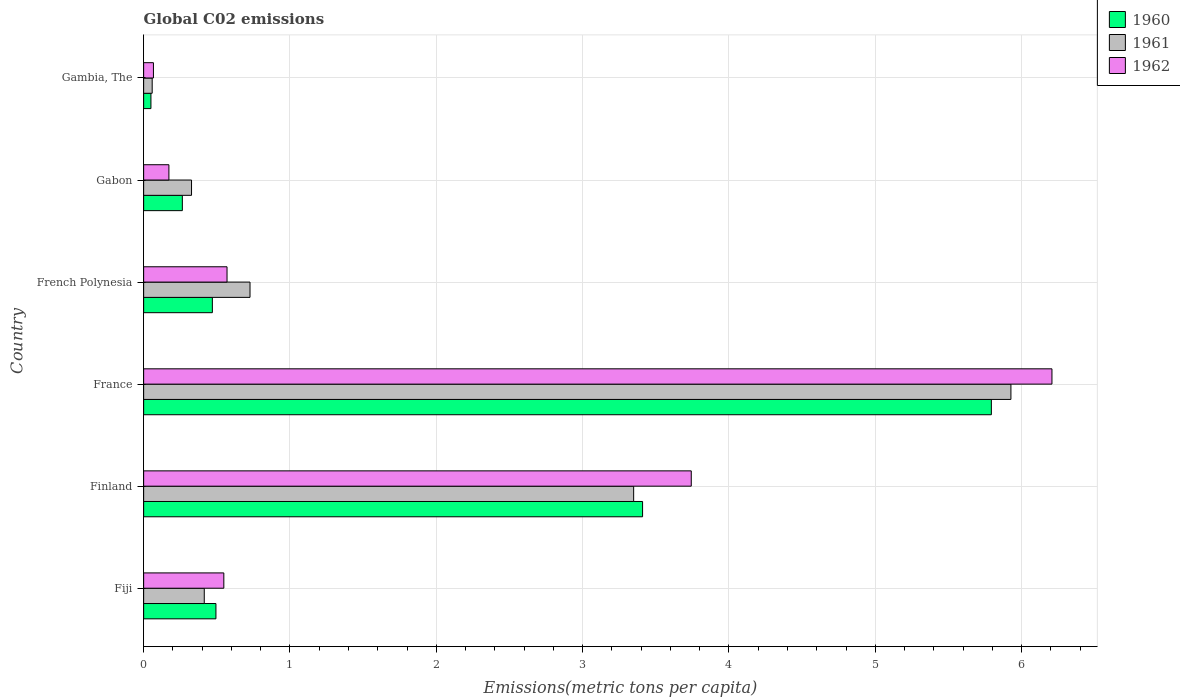Are the number of bars per tick equal to the number of legend labels?
Offer a terse response. Yes. How many bars are there on the 6th tick from the bottom?
Keep it short and to the point. 3. What is the label of the 4th group of bars from the top?
Your answer should be compact. France. What is the amount of CO2 emitted in in 1960 in France?
Your answer should be compact. 5.79. Across all countries, what is the maximum amount of CO2 emitted in in 1961?
Give a very brief answer. 5.93. Across all countries, what is the minimum amount of CO2 emitted in in 1960?
Provide a short and direct response. 0.05. In which country was the amount of CO2 emitted in in 1962 minimum?
Your answer should be very brief. Gambia, The. What is the total amount of CO2 emitted in in 1960 in the graph?
Your answer should be compact. 10.48. What is the difference between the amount of CO2 emitted in in 1960 in Finland and that in French Polynesia?
Provide a short and direct response. 2.94. What is the difference between the amount of CO2 emitted in in 1961 in French Polynesia and the amount of CO2 emitted in in 1960 in Finland?
Your answer should be very brief. -2.68. What is the average amount of CO2 emitted in in 1961 per country?
Keep it short and to the point. 1.8. What is the difference between the amount of CO2 emitted in in 1962 and amount of CO2 emitted in in 1961 in Fiji?
Provide a short and direct response. 0.13. In how many countries, is the amount of CO2 emitted in in 1960 greater than 2 metric tons per capita?
Offer a very short reply. 2. What is the ratio of the amount of CO2 emitted in in 1961 in Finland to that in France?
Your answer should be compact. 0.57. Is the difference between the amount of CO2 emitted in in 1962 in Finland and France greater than the difference between the amount of CO2 emitted in in 1961 in Finland and France?
Keep it short and to the point. Yes. What is the difference between the highest and the second highest amount of CO2 emitted in in 1960?
Provide a short and direct response. 2.38. What is the difference between the highest and the lowest amount of CO2 emitted in in 1962?
Your response must be concise. 6.14. In how many countries, is the amount of CO2 emitted in in 1961 greater than the average amount of CO2 emitted in in 1961 taken over all countries?
Your response must be concise. 2. Is it the case that in every country, the sum of the amount of CO2 emitted in in 1960 and amount of CO2 emitted in in 1962 is greater than the amount of CO2 emitted in in 1961?
Your answer should be compact. Yes. Are all the bars in the graph horizontal?
Your answer should be very brief. Yes. What is the difference between two consecutive major ticks on the X-axis?
Ensure brevity in your answer.  1. Does the graph contain grids?
Make the answer very short. Yes. Where does the legend appear in the graph?
Keep it short and to the point. Top right. How many legend labels are there?
Ensure brevity in your answer.  3. How are the legend labels stacked?
Offer a very short reply. Vertical. What is the title of the graph?
Your answer should be compact. Global C02 emissions. Does "1963" appear as one of the legend labels in the graph?
Provide a succinct answer. No. What is the label or title of the X-axis?
Your answer should be very brief. Emissions(metric tons per capita). What is the label or title of the Y-axis?
Provide a succinct answer. Country. What is the Emissions(metric tons per capita) of 1960 in Fiji?
Ensure brevity in your answer.  0.49. What is the Emissions(metric tons per capita) of 1961 in Fiji?
Ensure brevity in your answer.  0.41. What is the Emissions(metric tons per capita) of 1962 in Fiji?
Your answer should be very brief. 0.55. What is the Emissions(metric tons per capita) in 1960 in Finland?
Provide a succinct answer. 3.41. What is the Emissions(metric tons per capita) of 1961 in Finland?
Offer a very short reply. 3.35. What is the Emissions(metric tons per capita) in 1962 in Finland?
Keep it short and to the point. 3.74. What is the Emissions(metric tons per capita) in 1960 in France?
Offer a very short reply. 5.79. What is the Emissions(metric tons per capita) of 1961 in France?
Make the answer very short. 5.93. What is the Emissions(metric tons per capita) of 1962 in France?
Keep it short and to the point. 6.21. What is the Emissions(metric tons per capita) of 1960 in French Polynesia?
Offer a terse response. 0.47. What is the Emissions(metric tons per capita) in 1961 in French Polynesia?
Provide a short and direct response. 0.73. What is the Emissions(metric tons per capita) of 1962 in French Polynesia?
Your answer should be compact. 0.57. What is the Emissions(metric tons per capita) in 1960 in Gabon?
Your answer should be very brief. 0.26. What is the Emissions(metric tons per capita) in 1961 in Gabon?
Make the answer very short. 0.33. What is the Emissions(metric tons per capita) of 1962 in Gabon?
Make the answer very short. 0.17. What is the Emissions(metric tons per capita) in 1960 in Gambia, The?
Offer a very short reply. 0.05. What is the Emissions(metric tons per capita) of 1961 in Gambia, The?
Provide a short and direct response. 0.06. What is the Emissions(metric tons per capita) in 1962 in Gambia, The?
Keep it short and to the point. 0.07. Across all countries, what is the maximum Emissions(metric tons per capita) in 1960?
Make the answer very short. 5.79. Across all countries, what is the maximum Emissions(metric tons per capita) in 1961?
Keep it short and to the point. 5.93. Across all countries, what is the maximum Emissions(metric tons per capita) of 1962?
Your answer should be very brief. 6.21. Across all countries, what is the minimum Emissions(metric tons per capita) in 1960?
Your response must be concise. 0.05. Across all countries, what is the minimum Emissions(metric tons per capita) of 1961?
Provide a succinct answer. 0.06. Across all countries, what is the minimum Emissions(metric tons per capita) in 1962?
Give a very brief answer. 0.07. What is the total Emissions(metric tons per capita) of 1960 in the graph?
Keep it short and to the point. 10.48. What is the total Emissions(metric tons per capita) of 1961 in the graph?
Make the answer very short. 10.8. What is the total Emissions(metric tons per capita) of 1962 in the graph?
Give a very brief answer. 11.31. What is the difference between the Emissions(metric tons per capita) in 1960 in Fiji and that in Finland?
Your response must be concise. -2.92. What is the difference between the Emissions(metric tons per capita) in 1961 in Fiji and that in Finland?
Give a very brief answer. -2.93. What is the difference between the Emissions(metric tons per capita) of 1962 in Fiji and that in Finland?
Give a very brief answer. -3.19. What is the difference between the Emissions(metric tons per capita) of 1960 in Fiji and that in France?
Keep it short and to the point. -5.3. What is the difference between the Emissions(metric tons per capita) in 1961 in Fiji and that in France?
Keep it short and to the point. -5.51. What is the difference between the Emissions(metric tons per capita) of 1962 in Fiji and that in France?
Provide a short and direct response. -5.66. What is the difference between the Emissions(metric tons per capita) in 1960 in Fiji and that in French Polynesia?
Offer a terse response. 0.02. What is the difference between the Emissions(metric tons per capita) in 1961 in Fiji and that in French Polynesia?
Your answer should be compact. -0.31. What is the difference between the Emissions(metric tons per capita) in 1962 in Fiji and that in French Polynesia?
Your answer should be very brief. -0.02. What is the difference between the Emissions(metric tons per capita) in 1960 in Fiji and that in Gabon?
Your response must be concise. 0.23. What is the difference between the Emissions(metric tons per capita) of 1961 in Fiji and that in Gabon?
Make the answer very short. 0.09. What is the difference between the Emissions(metric tons per capita) of 1962 in Fiji and that in Gabon?
Ensure brevity in your answer.  0.38. What is the difference between the Emissions(metric tons per capita) of 1960 in Fiji and that in Gambia, The?
Offer a terse response. 0.44. What is the difference between the Emissions(metric tons per capita) of 1961 in Fiji and that in Gambia, The?
Keep it short and to the point. 0.36. What is the difference between the Emissions(metric tons per capita) in 1962 in Fiji and that in Gambia, The?
Ensure brevity in your answer.  0.48. What is the difference between the Emissions(metric tons per capita) in 1960 in Finland and that in France?
Offer a very short reply. -2.38. What is the difference between the Emissions(metric tons per capita) of 1961 in Finland and that in France?
Your answer should be compact. -2.58. What is the difference between the Emissions(metric tons per capita) of 1962 in Finland and that in France?
Make the answer very short. -2.46. What is the difference between the Emissions(metric tons per capita) in 1960 in Finland and that in French Polynesia?
Your answer should be compact. 2.94. What is the difference between the Emissions(metric tons per capita) in 1961 in Finland and that in French Polynesia?
Give a very brief answer. 2.62. What is the difference between the Emissions(metric tons per capita) in 1962 in Finland and that in French Polynesia?
Give a very brief answer. 3.17. What is the difference between the Emissions(metric tons per capita) of 1960 in Finland and that in Gabon?
Ensure brevity in your answer.  3.15. What is the difference between the Emissions(metric tons per capita) of 1961 in Finland and that in Gabon?
Your response must be concise. 3.02. What is the difference between the Emissions(metric tons per capita) of 1962 in Finland and that in Gabon?
Your response must be concise. 3.57. What is the difference between the Emissions(metric tons per capita) in 1960 in Finland and that in Gambia, The?
Your response must be concise. 3.36. What is the difference between the Emissions(metric tons per capita) in 1961 in Finland and that in Gambia, The?
Give a very brief answer. 3.29. What is the difference between the Emissions(metric tons per capita) in 1962 in Finland and that in Gambia, The?
Offer a terse response. 3.68. What is the difference between the Emissions(metric tons per capita) in 1960 in France and that in French Polynesia?
Keep it short and to the point. 5.32. What is the difference between the Emissions(metric tons per capita) of 1961 in France and that in French Polynesia?
Offer a terse response. 5.2. What is the difference between the Emissions(metric tons per capita) of 1962 in France and that in French Polynesia?
Offer a very short reply. 5.64. What is the difference between the Emissions(metric tons per capita) of 1960 in France and that in Gabon?
Your answer should be compact. 5.53. What is the difference between the Emissions(metric tons per capita) in 1961 in France and that in Gabon?
Offer a very short reply. 5.6. What is the difference between the Emissions(metric tons per capita) in 1962 in France and that in Gabon?
Your answer should be compact. 6.03. What is the difference between the Emissions(metric tons per capita) in 1960 in France and that in Gambia, The?
Give a very brief answer. 5.74. What is the difference between the Emissions(metric tons per capita) of 1961 in France and that in Gambia, The?
Your answer should be compact. 5.87. What is the difference between the Emissions(metric tons per capita) of 1962 in France and that in Gambia, The?
Your answer should be compact. 6.14. What is the difference between the Emissions(metric tons per capita) of 1960 in French Polynesia and that in Gabon?
Offer a terse response. 0.21. What is the difference between the Emissions(metric tons per capita) in 1961 in French Polynesia and that in Gabon?
Ensure brevity in your answer.  0.4. What is the difference between the Emissions(metric tons per capita) in 1962 in French Polynesia and that in Gabon?
Keep it short and to the point. 0.4. What is the difference between the Emissions(metric tons per capita) in 1960 in French Polynesia and that in Gambia, The?
Offer a terse response. 0.42. What is the difference between the Emissions(metric tons per capita) of 1961 in French Polynesia and that in Gambia, The?
Your response must be concise. 0.67. What is the difference between the Emissions(metric tons per capita) in 1962 in French Polynesia and that in Gambia, The?
Offer a terse response. 0.5. What is the difference between the Emissions(metric tons per capita) of 1960 in Gabon and that in Gambia, The?
Provide a succinct answer. 0.21. What is the difference between the Emissions(metric tons per capita) of 1961 in Gabon and that in Gambia, The?
Offer a terse response. 0.27. What is the difference between the Emissions(metric tons per capita) of 1962 in Gabon and that in Gambia, The?
Your response must be concise. 0.11. What is the difference between the Emissions(metric tons per capita) in 1960 in Fiji and the Emissions(metric tons per capita) in 1961 in Finland?
Provide a short and direct response. -2.85. What is the difference between the Emissions(metric tons per capita) of 1960 in Fiji and the Emissions(metric tons per capita) of 1962 in Finland?
Make the answer very short. -3.25. What is the difference between the Emissions(metric tons per capita) of 1961 in Fiji and the Emissions(metric tons per capita) of 1962 in Finland?
Provide a succinct answer. -3.33. What is the difference between the Emissions(metric tons per capita) in 1960 in Fiji and the Emissions(metric tons per capita) in 1961 in France?
Your answer should be compact. -5.43. What is the difference between the Emissions(metric tons per capita) of 1960 in Fiji and the Emissions(metric tons per capita) of 1962 in France?
Make the answer very short. -5.71. What is the difference between the Emissions(metric tons per capita) of 1961 in Fiji and the Emissions(metric tons per capita) of 1962 in France?
Provide a short and direct response. -5.79. What is the difference between the Emissions(metric tons per capita) in 1960 in Fiji and the Emissions(metric tons per capita) in 1961 in French Polynesia?
Ensure brevity in your answer.  -0.23. What is the difference between the Emissions(metric tons per capita) in 1960 in Fiji and the Emissions(metric tons per capita) in 1962 in French Polynesia?
Your answer should be compact. -0.08. What is the difference between the Emissions(metric tons per capita) of 1961 in Fiji and the Emissions(metric tons per capita) of 1962 in French Polynesia?
Make the answer very short. -0.16. What is the difference between the Emissions(metric tons per capita) in 1960 in Fiji and the Emissions(metric tons per capita) in 1961 in Gabon?
Keep it short and to the point. 0.17. What is the difference between the Emissions(metric tons per capita) of 1960 in Fiji and the Emissions(metric tons per capita) of 1962 in Gabon?
Your answer should be very brief. 0.32. What is the difference between the Emissions(metric tons per capita) in 1961 in Fiji and the Emissions(metric tons per capita) in 1962 in Gabon?
Provide a succinct answer. 0.24. What is the difference between the Emissions(metric tons per capita) in 1960 in Fiji and the Emissions(metric tons per capita) in 1961 in Gambia, The?
Provide a succinct answer. 0.44. What is the difference between the Emissions(metric tons per capita) in 1960 in Fiji and the Emissions(metric tons per capita) in 1962 in Gambia, The?
Offer a terse response. 0.43. What is the difference between the Emissions(metric tons per capita) in 1961 in Fiji and the Emissions(metric tons per capita) in 1962 in Gambia, The?
Your answer should be very brief. 0.35. What is the difference between the Emissions(metric tons per capita) in 1960 in Finland and the Emissions(metric tons per capita) in 1961 in France?
Offer a very short reply. -2.52. What is the difference between the Emissions(metric tons per capita) in 1960 in Finland and the Emissions(metric tons per capita) in 1962 in France?
Provide a short and direct response. -2.8. What is the difference between the Emissions(metric tons per capita) of 1961 in Finland and the Emissions(metric tons per capita) of 1962 in France?
Offer a very short reply. -2.86. What is the difference between the Emissions(metric tons per capita) of 1960 in Finland and the Emissions(metric tons per capita) of 1961 in French Polynesia?
Give a very brief answer. 2.68. What is the difference between the Emissions(metric tons per capita) of 1960 in Finland and the Emissions(metric tons per capita) of 1962 in French Polynesia?
Provide a short and direct response. 2.84. What is the difference between the Emissions(metric tons per capita) in 1961 in Finland and the Emissions(metric tons per capita) in 1962 in French Polynesia?
Offer a very short reply. 2.78. What is the difference between the Emissions(metric tons per capita) in 1960 in Finland and the Emissions(metric tons per capita) in 1961 in Gabon?
Provide a short and direct response. 3.08. What is the difference between the Emissions(metric tons per capita) in 1960 in Finland and the Emissions(metric tons per capita) in 1962 in Gabon?
Make the answer very short. 3.24. What is the difference between the Emissions(metric tons per capita) in 1961 in Finland and the Emissions(metric tons per capita) in 1962 in Gabon?
Provide a succinct answer. 3.18. What is the difference between the Emissions(metric tons per capita) of 1960 in Finland and the Emissions(metric tons per capita) of 1961 in Gambia, The?
Your answer should be compact. 3.35. What is the difference between the Emissions(metric tons per capita) of 1960 in Finland and the Emissions(metric tons per capita) of 1962 in Gambia, The?
Give a very brief answer. 3.34. What is the difference between the Emissions(metric tons per capita) of 1961 in Finland and the Emissions(metric tons per capita) of 1962 in Gambia, The?
Keep it short and to the point. 3.28. What is the difference between the Emissions(metric tons per capita) in 1960 in France and the Emissions(metric tons per capita) in 1961 in French Polynesia?
Give a very brief answer. 5.07. What is the difference between the Emissions(metric tons per capita) of 1960 in France and the Emissions(metric tons per capita) of 1962 in French Polynesia?
Provide a short and direct response. 5.22. What is the difference between the Emissions(metric tons per capita) in 1961 in France and the Emissions(metric tons per capita) in 1962 in French Polynesia?
Offer a terse response. 5.36. What is the difference between the Emissions(metric tons per capita) of 1960 in France and the Emissions(metric tons per capita) of 1961 in Gabon?
Make the answer very short. 5.47. What is the difference between the Emissions(metric tons per capita) of 1960 in France and the Emissions(metric tons per capita) of 1962 in Gabon?
Your answer should be compact. 5.62. What is the difference between the Emissions(metric tons per capita) of 1961 in France and the Emissions(metric tons per capita) of 1962 in Gabon?
Give a very brief answer. 5.75. What is the difference between the Emissions(metric tons per capita) in 1960 in France and the Emissions(metric tons per capita) in 1961 in Gambia, The?
Ensure brevity in your answer.  5.74. What is the difference between the Emissions(metric tons per capita) of 1960 in France and the Emissions(metric tons per capita) of 1962 in Gambia, The?
Give a very brief answer. 5.73. What is the difference between the Emissions(metric tons per capita) in 1961 in France and the Emissions(metric tons per capita) in 1962 in Gambia, The?
Give a very brief answer. 5.86. What is the difference between the Emissions(metric tons per capita) in 1960 in French Polynesia and the Emissions(metric tons per capita) in 1961 in Gabon?
Provide a short and direct response. 0.14. What is the difference between the Emissions(metric tons per capita) in 1960 in French Polynesia and the Emissions(metric tons per capita) in 1962 in Gabon?
Provide a succinct answer. 0.3. What is the difference between the Emissions(metric tons per capita) in 1961 in French Polynesia and the Emissions(metric tons per capita) in 1962 in Gabon?
Your answer should be very brief. 0.55. What is the difference between the Emissions(metric tons per capita) in 1960 in French Polynesia and the Emissions(metric tons per capita) in 1961 in Gambia, The?
Make the answer very short. 0.41. What is the difference between the Emissions(metric tons per capita) of 1960 in French Polynesia and the Emissions(metric tons per capita) of 1962 in Gambia, The?
Keep it short and to the point. 0.4. What is the difference between the Emissions(metric tons per capita) in 1961 in French Polynesia and the Emissions(metric tons per capita) in 1962 in Gambia, The?
Your answer should be very brief. 0.66. What is the difference between the Emissions(metric tons per capita) of 1960 in Gabon and the Emissions(metric tons per capita) of 1961 in Gambia, The?
Ensure brevity in your answer.  0.21. What is the difference between the Emissions(metric tons per capita) of 1960 in Gabon and the Emissions(metric tons per capita) of 1962 in Gambia, The?
Ensure brevity in your answer.  0.2. What is the difference between the Emissions(metric tons per capita) in 1961 in Gabon and the Emissions(metric tons per capita) in 1962 in Gambia, The?
Offer a terse response. 0.26. What is the average Emissions(metric tons per capita) of 1960 per country?
Provide a short and direct response. 1.75. What is the average Emissions(metric tons per capita) in 1961 per country?
Offer a terse response. 1.8. What is the average Emissions(metric tons per capita) of 1962 per country?
Your answer should be compact. 1.88. What is the difference between the Emissions(metric tons per capita) of 1960 and Emissions(metric tons per capita) of 1961 in Fiji?
Your response must be concise. 0.08. What is the difference between the Emissions(metric tons per capita) of 1960 and Emissions(metric tons per capita) of 1962 in Fiji?
Offer a terse response. -0.05. What is the difference between the Emissions(metric tons per capita) of 1961 and Emissions(metric tons per capita) of 1962 in Fiji?
Provide a succinct answer. -0.13. What is the difference between the Emissions(metric tons per capita) of 1960 and Emissions(metric tons per capita) of 1961 in Finland?
Ensure brevity in your answer.  0.06. What is the difference between the Emissions(metric tons per capita) of 1960 and Emissions(metric tons per capita) of 1962 in Finland?
Provide a succinct answer. -0.33. What is the difference between the Emissions(metric tons per capita) in 1961 and Emissions(metric tons per capita) in 1962 in Finland?
Offer a very short reply. -0.39. What is the difference between the Emissions(metric tons per capita) of 1960 and Emissions(metric tons per capita) of 1961 in France?
Provide a succinct answer. -0.13. What is the difference between the Emissions(metric tons per capita) in 1960 and Emissions(metric tons per capita) in 1962 in France?
Your answer should be compact. -0.41. What is the difference between the Emissions(metric tons per capita) in 1961 and Emissions(metric tons per capita) in 1962 in France?
Keep it short and to the point. -0.28. What is the difference between the Emissions(metric tons per capita) in 1960 and Emissions(metric tons per capita) in 1961 in French Polynesia?
Your answer should be very brief. -0.26. What is the difference between the Emissions(metric tons per capita) in 1960 and Emissions(metric tons per capita) in 1962 in French Polynesia?
Keep it short and to the point. -0.1. What is the difference between the Emissions(metric tons per capita) of 1961 and Emissions(metric tons per capita) of 1962 in French Polynesia?
Provide a short and direct response. 0.16. What is the difference between the Emissions(metric tons per capita) in 1960 and Emissions(metric tons per capita) in 1961 in Gabon?
Your answer should be compact. -0.06. What is the difference between the Emissions(metric tons per capita) of 1960 and Emissions(metric tons per capita) of 1962 in Gabon?
Your response must be concise. 0.09. What is the difference between the Emissions(metric tons per capita) in 1961 and Emissions(metric tons per capita) in 1962 in Gabon?
Offer a very short reply. 0.15. What is the difference between the Emissions(metric tons per capita) of 1960 and Emissions(metric tons per capita) of 1961 in Gambia, The?
Provide a succinct answer. -0.01. What is the difference between the Emissions(metric tons per capita) of 1960 and Emissions(metric tons per capita) of 1962 in Gambia, The?
Your response must be concise. -0.02. What is the difference between the Emissions(metric tons per capita) in 1961 and Emissions(metric tons per capita) in 1962 in Gambia, The?
Your response must be concise. -0.01. What is the ratio of the Emissions(metric tons per capita) of 1960 in Fiji to that in Finland?
Give a very brief answer. 0.14. What is the ratio of the Emissions(metric tons per capita) in 1961 in Fiji to that in Finland?
Make the answer very short. 0.12. What is the ratio of the Emissions(metric tons per capita) of 1962 in Fiji to that in Finland?
Your answer should be compact. 0.15. What is the ratio of the Emissions(metric tons per capita) in 1960 in Fiji to that in France?
Provide a succinct answer. 0.09. What is the ratio of the Emissions(metric tons per capita) of 1961 in Fiji to that in France?
Your answer should be very brief. 0.07. What is the ratio of the Emissions(metric tons per capita) in 1962 in Fiji to that in France?
Offer a very short reply. 0.09. What is the ratio of the Emissions(metric tons per capita) of 1960 in Fiji to that in French Polynesia?
Offer a terse response. 1.05. What is the ratio of the Emissions(metric tons per capita) in 1961 in Fiji to that in French Polynesia?
Offer a very short reply. 0.57. What is the ratio of the Emissions(metric tons per capita) in 1962 in Fiji to that in French Polynesia?
Provide a succinct answer. 0.96. What is the ratio of the Emissions(metric tons per capita) in 1960 in Fiji to that in Gabon?
Offer a terse response. 1.87. What is the ratio of the Emissions(metric tons per capita) in 1961 in Fiji to that in Gabon?
Keep it short and to the point. 1.27. What is the ratio of the Emissions(metric tons per capita) in 1962 in Fiji to that in Gabon?
Offer a terse response. 3.17. What is the ratio of the Emissions(metric tons per capita) of 1960 in Fiji to that in Gambia, The?
Offer a terse response. 9.91. What is the ratio of the Emissions(metric tons per capita) in 1961 in Fiji to that in Gambia, The?
Your answer should be very brief. 7.09. What is the ratio of the Emissions(metric tons per capita) of 1962 in Fiji to that in Gambia, The?
Your answer should be compact. 8.19. What is the ratio of the Emissions(metric tons per capita) in 1960 in Finland to that in France?
Provide a succinct answer. 0.59. What is the ratio of the Emissions(metric tons per capita) of 1961 in Finland to that in France?
Provide a short and direct response. 0.56. What is the ratio of the Emissions(metric tons per capita) of 1962 in Finland to that in France?
Offer a terse response. 0.6. What is the ratio of the Emissions(metric tons per capita) in 1960 in Finland to that in French Polynesia?
Your answer should be very brief. 7.26. What is the ratio of the Emissions(metric tons per capita) of 1961 in Finland to that in French Polynesia?
Provide a succinct answer. 4.61. What is the ratio of the Emissions(metric tons per capita) in 1962 in Finland to that in French Polynesia?
Ensure brevity in your answer.  6.57. What is the ratio of the Emissions(metric tons per capita) in 1960 in Finland to that in Gabon?
Make the answer very short. 12.89. What is the ratio of the Emissions(metric tons per capita) of 1961 in Finland to that in Gabon?
Provide a short and direct response. 10.23. What is the ratio of the Emissions(metric tons per capita) in 1962 in Finland to that in Gabon?
Your answer should be very brief. 21.68. What is the ratio of the Emissions(metric tons per capita) of 1960 in Finland to that in Gambia, The?
Make the answer very short. 68.43. What is the ratio of the Emissions(metric tons per capita) of 1961 in Finland to that in Gambia, The?
Your response must be concise. 57.34. What is the ratio of the Emissions(metric tons per capita) of 1962 in Finland to that in Gambia, The?
Ensure brevity in your answer.  55.92. What is the ratio of the Emissions(metric tons per capita) of 1960 in France to that in French Polynesia?
Your response must be concise. 12.34. What is the ratio of the Emissions(metric tons per capita) in 1961 in France to that in French Polynesia?
Provide a short and direct response. 8.15. What is the ratio of the Emissions(metric tons per capita) in 1962 in France to that in French Polynesia?
Offer a terse response. 10.89. What is the ratio of the Emissions(metric tons per capita) of 1960 in France to that in Gabon?
Make the answer very short. 21.91. What is the ratio of the Emissions(metric tons per capita) of 1961 in France to that in Gabon?
Provide a succinct answer. 18.11. What is the ratio of the Emissions(metric tons per capita) in 1962 in France to that in Gabon?
Provide a succinct answer. 35.96. What is the ratio of the Emissions(metric tons per capita) in 1960 in France to that in Gambia, The?
Make the answer very short. 116.26. What is the ratio of the Emissions(metric tons per capita) of 1961 in France to that in Gambia, The?
Make the answer very short. 101.49. What is the ratio of the Emissions(metric tons per capita) in 1962 in France to that in Gambia, The?
Your answer should be very brief. 92.75. What is the ratio of the Emissions(metric tons per capita) in 1960 in French Polynesia to that in Gabon?
Offer a very short reply. 1.78. What is the ratio of the Emissions(metric tons per capita) in 1961 in French Polynesia to that in Gabon?
Keep it short and to the point. 2.22. What is the ratio of the Emissions(metric tons per capita) in 1962 in French Polynesia to that in Gabon?
Your answer should be very brief. 3.3. What is the ratio of the Emissions(metric tons per capita) of 1960 in French Polynesia to that in Gambia, The?
Offer a terse response. 9.42. What is the ratio of the Emissions(metric tons per capita) of 1961 in French Polynesia to that in Gambia, The?
Make the answer very short. 12.45. What is the ratio of the Emissions(metric tons per capita) of 1962 in French Polynesia to that in Gambia, The?
Offer a terse response. 8.51. What is the ratio of the Emissions(metric tons per capita) in 1960 in Gabon to that in Gambia, The?
Keep it short and to the point. 5.31. What is the ratio of the Emissions(metric tons per capita) of 1961 in Gabon to that in Gambia, The?
Give a very brief answer. 5.6. What is the ratio of the Emissions(metric tons per capita) in 1962 in Gabon to that in Gambia, The?
Offer a terse response. 2.58. What is the difference between the highest and the second highest Emissions(metric tons per capita) of 1960?
Make the answer very short. 2.38. What is the difference between the highest and the second highest Emissions(metric tons per capita) of 1961?
Offer a very short reply. 2.58. What is the difference between the highest and the second highest Emissions(metric tons per capita) in 1962?
Give a very brief answer. 2.46. What is the difference between the highest and the lowest Emissions(metric tons per capita) in 1960?
Offer a terse response. 5.74. What is the difference between the highest and the lowest Emissions(metric tons per capita) of 1961?
Provide a succinct answer. 5.87. What is the difference between the highest and the lowest Emissions(metric tons per capita) in 1962?
Make the answer very short. 6.14. 